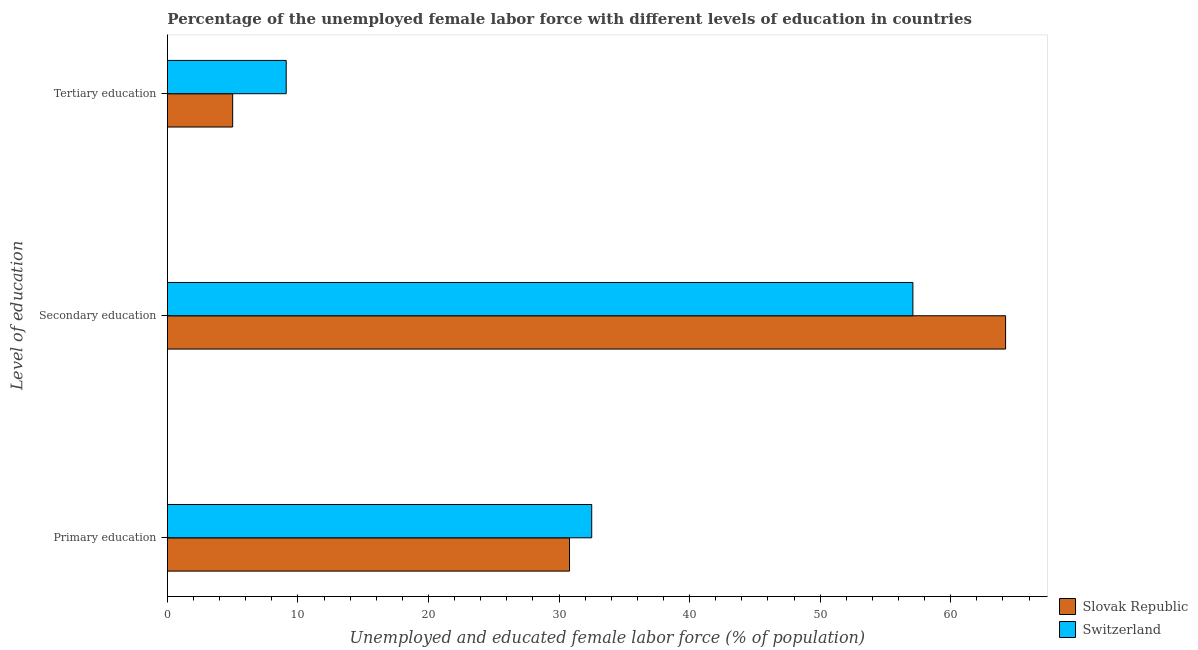How many groups of bars are there?
Keep it short and to the point. 3. Are the number of bars per tick equal to the number of legend labels?
Make the answer very short. Yes. What is the label of the 1st group of bars from the top?
Provide a succinct answer. Tertiary education. What is the percentage of female labor force who received secondary education in Slovak Republic?
Provide a short and direct response. 64.2. Across all countries, what is the maximum percentage of female labor force who received tertiary education?
Your response must be concise. 9.1. Across all countries, what is the minimum percentage of female labor force who received primary education?
Offer a terse response. 30.8. In which country was the percentage of female labor force who received primary education maximum?
Provide a succinct answer. Switzerland. In which country was the percentage of female labor force who received tertiary education minimum?
Your answer should be compact. Slovak Republic. What is the total percentage of female labor force who received primary education in the graph?
Make the answer very short. 63.3. What is the difference between the percentage of female labor force who received secondary education in Switzerland and that in Slovak Republic?
Offer a very short reply. -7.1. What is the difference between the percentage of female labor force who received primary education in Slovak Republic and the percentage of female labor force who received tertiary education in Switzerland?
Your response must be concise. 21.7. What is the average percentage of female labor force who received secondary education per country?
Your answer should be very brief. 60.65. What is the difference between the percentage of female labor force who received tertiary education and percentage of female labor force who received primary education in Switzerland?
Ensure brevity in your answer.  -23.4. What is the ratio of the percentage of female labor force who received tertiary education in Slovak Republic to that in Switzerland?
Give a very brief answer. 0.55. What is the difference between the highest and the second highest percentage of female labor force who received tertiary education?
Give a very brief answer. 4.1. What is the difference between the highest and the lowest percentage of female labor force who received primary education?
Give a very brief answer. 1.7. In how many countries, is the percentage of female labor force who received primary education greater than the average percentage of female labor force who received primary education taken over all countries?
Your response must be concise. 1. What does the 2nd bar from the top in Secondary education represents?
Provide a succinct answer. Slovak Republic. What does the 1st bar from the bottom in Secondary education represents?
Provide a succinct answer. Slovak Republic. Is it the case that in every country, the sum of the percentage of female labor force who received primary education and percentage of female labor force who received secondary education is greater than the percentage of female labor force who received tertiary education?
Ensure brevity in your answer.  Yes. Are the values on the major ticks of X-axis written in scientific E-notation?
Provide a short and direct response. No. What is the title of the graph?
Make the answer very short. Percentage of the unemployed female labor force with different levels of education in countries. What is the label or title of the X-axis?
Your answer should be compact. Unemployed and educated female labor force (% of population). What is the label or title of the Y-axis?
Your answer should be compact. Level of education. What is the Unemployed and educated female labor force (% of population) in Slovak Republic in Primary education?
Provide a short and direct response. 30.8. What is the Unemployed and educated female labor force (% of population) in Switzerland in Primary education?
Give a very brief answer. 32.5. What is the Unemployed and educated female labor force (% of population) in Slovak Republic in Secondary education?
Offer a very short reply. 64.2. What is the Unemployed and educated female labor force (% of population) in Switzerland in Secondary education?
Ensure brevity in your answer.  57.1. What is the Unemployed and educated female labor force (% of population) in Switzerland in Tertiary education?
Your answer should be very brief. 9.1. Across all Level of education, what is the maximum Unemployed and educated female labor force (% of population) in Slovak Republic?
Ensure brevity in your answer.  64.2. Across all Level of education, what is the maximum Unemployed and educated female labor force (% of population) in Switzerland?
Keep it short and to the point. 57.1. Across all Level of education, what is the minimum Unemployed and educated female labor force (% of population) in Slovak Republic?
Give a very brief answer. 5. Across all Level of education, what is the minimum Unemployed and educated female labor force (% of population) of Switzerland?
Your response must be concise. 9.1. What is the total Unemployed and educated female labor force (% of population) of Slovak Republic in the graph?
Give a very brief answer. 100. What is the total Unemployed and educated female labor force (% of population) of Switzerland in the graph?
Provide a succinct answer. 98.7. What is the difference between the Unemployed and educated female labor force (% of population) in Slovak Republic in Primary education and that in Secondary education?
Ensure brevity in your answer.  -33.4. What is the difference between the Unemployed and educated female labor force (% of population) in Switzerland in Primary education and that in Secondary education?
Offer a very short reply. -24.6. What is the difference between the Unemployed and educated female labor force (% of population) in Slovak Republic in Primary education and that in Tertiary education?
Your answer should be compact. 25.8. What is the difference between the Unemployed and educated female labor force (% of population) of Switzerland in Primary education and that in Tertiary education?
Your response must be concise. 23.4. What is the difference between the Unemployed and educated female labor force (% of population) of Slovak Republic in Secondary education and that in Tertiary education?
Ensure brevity in your answer.  59.2. What is the difference between the Unemployed and educated female labor force (% of population) of Slovak Republic in Primary education and the Unemployed and educated female labor force (% of population) of Switzerland in Secondary education?
Ensure brevity in your answer.  -26.3. What is the difference between the Unemployed and educated female labor force (% of population) in Slovak Republic in Primary education and the Unemployed and educated female labor force (% of population) in Switzerland in Tertiary education?
Make the answer very short. 21.7. What is the difference between the Unemployed and educated female labor force (% of population) in Slovak Republic in Secondary education and the Unemployed and educated female labor force (% of population) in Switzerland in Tertiary education?
Ensure brevity in your answer.  55.1. What is the average Unemployed and educated female labor force (% of population) in Slovak Republic per Level of education?
Provide a short and direct response. 33.33. What is the average Unemployed and educated female labor force (% of population) of Switzerland per Level of education?
Your response must be concise. 32.9. What is the ratio of the Unemployed and educated female labor force (% of population) of Slovak Republic in Primary education to that in Secondary education?
Offer a very short reply. 0.48. What is the ratio of the Unemployed and educated female labor force (% of population) in Switzerland in Primary education to that in Secondary education?
Ensure brevity in your answer.  0.57. What is the ratio of the Unemployed and educated female labor force (% of population) of Slovak Republic in Primary education to that in Tertiary education?
Give a very brief answer. 6.16. What is the ratio of the Unemployed and educated female labor force (% of population) of Switzerland in Primary education to that in Tertiary education?
Your response must be concise. 3.57. What is the ratio of the Unemployed and educated female labor force (% of population) of Slovak Republic in Secondary education to that in Tertiary education?
Ensure brevity in your answer.  12.84. What is the ratio of the Unemployed and educated female labor force (% of population) of Switzerland in Secondary education to that in Tertiary education?
Your response must be concise. 6.27. What is the difference between the highest and the second highest Unemployed and educated female labor force (% of population) in Slovak Republic?
Offer a very short reply. 33.4. What is the difference between the highest and the second highest Unemployed and educated female labor force (% of population) in Switzerland?
Your response must be concise. 24.6. What is the difference between the highest and the lowest Unemployed and educated female labor force (% of population) of Slovak Republic?
Provide a short and direct response. 59.2. What is the difference between the highest and the lowest Unemployed and educated female labor force (% of population) of Switzerland?
Provide a short and direct response. 48. 